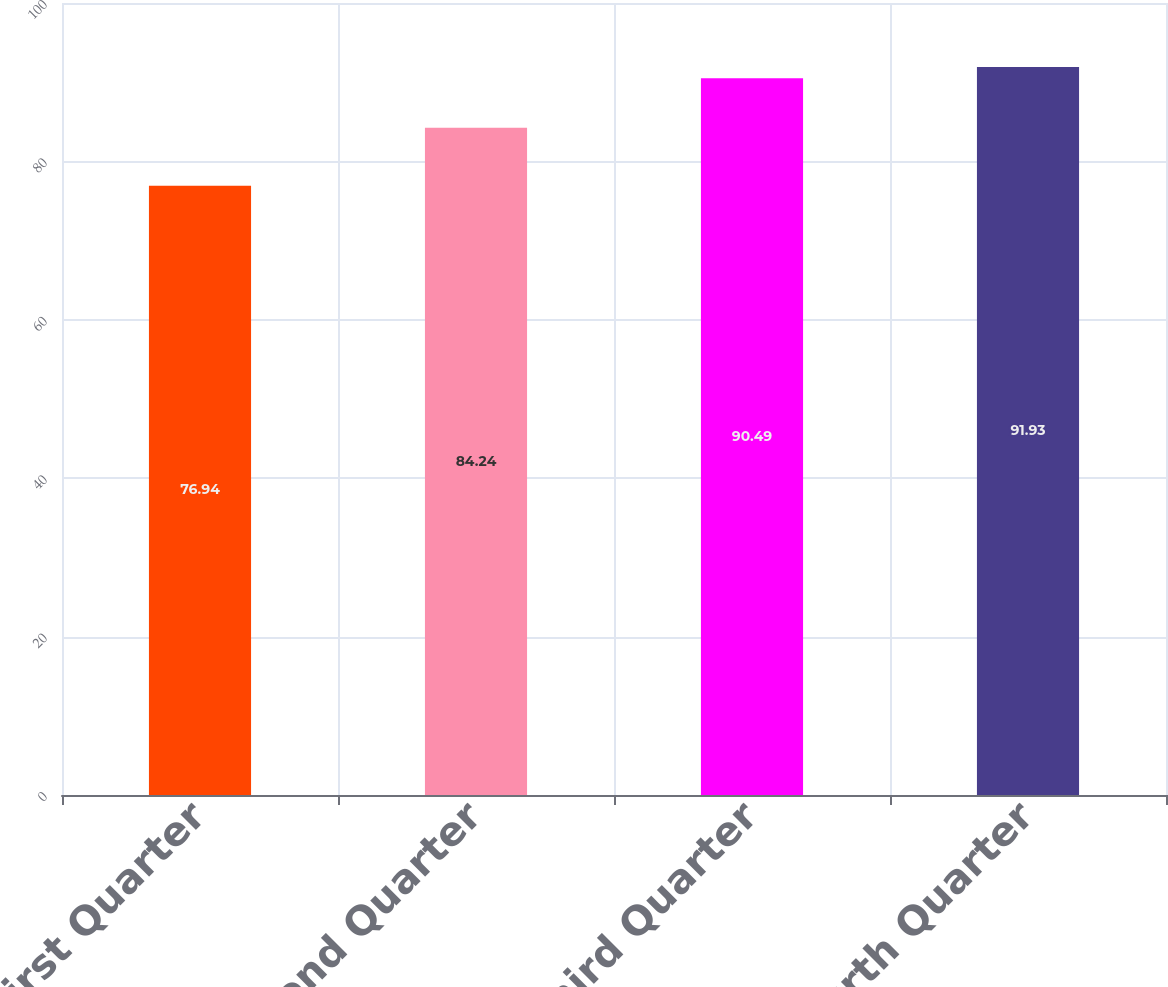Convert chart. <chart><loc_0><loc_0><loc_500><loc_500><bar_chart><fcel>First Quarter<fcel>Second Quarter<fcel>Third Quarter<fcel>Fourth Quarter<nl><fcel>76.94<fcel>84.24<fcel>90.49<fcel>91.93<nl></chart> 